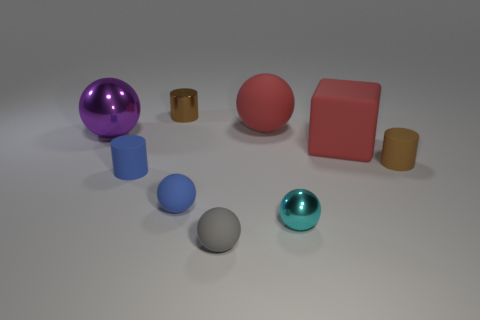What number of large objects are either green shiny objects or gray rubber spheres?
Offer a terse response. 0. There is a tiny rubber cylinder that is behind the small blue cylinder; is it the same color as the small shiny thing behind the tiny blue cylinder?
Offer a terse response. Yes. How many other things are there of the same color as the big shiny ball?
Your response must be concise. 0. What number of brown objects are big things or matte cubes?
Ensure brevity in your answer.  0. There is a gray matte object; does it have the same shape as the large red rubber thing that is to the left of the big rubber block?
Offer a terse response. Yes. There is a brown rubber thing; what shape is it?
Your answer should be compact. Cylinder. There is a gray ball that is the same size as the brown matte cylinder; what material is it?
Ensure brevity in your answer.  Rubber. How many objects are either purple balls or small matte cylinders in front of the small brown rubber cylinder?
Your answer should be compact. 2. The brown thing that is the same material as the gray ball is what size?
Make the answer very short. Small. The tiny shiny object in front of the brown cylinder on the right side of the cyan sphere is what shape?
Your answer should be compact. Sphere. 